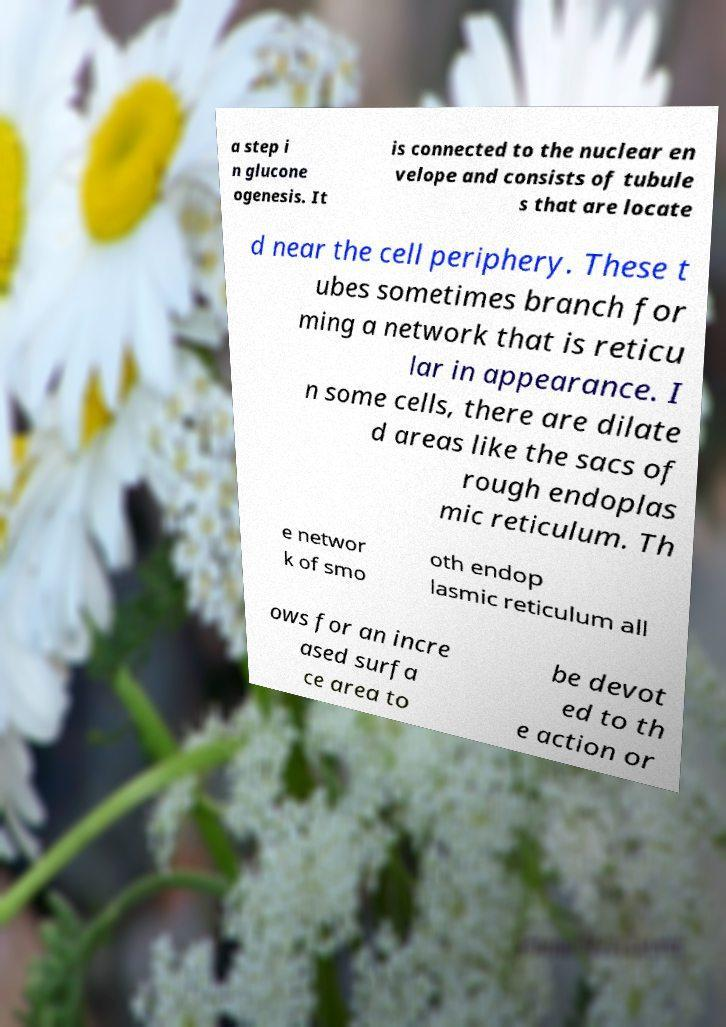Can you accurately transcribe the text from the provided image for me? a step i n glucone ogenesis. It is connected to the nuclear en velope and consists of tubule s that are locate d near the cell periphery. These t ubes sometimes branch for ming a network that is reticu lar in appearance. I n some cells, there are dilate d areas like the sacs of rough endoplas mic reticulum. Th e networ k of smo oth endop lasmic reticulum all ows for an incre ased surfa ce area to be devot ed to th e action or 